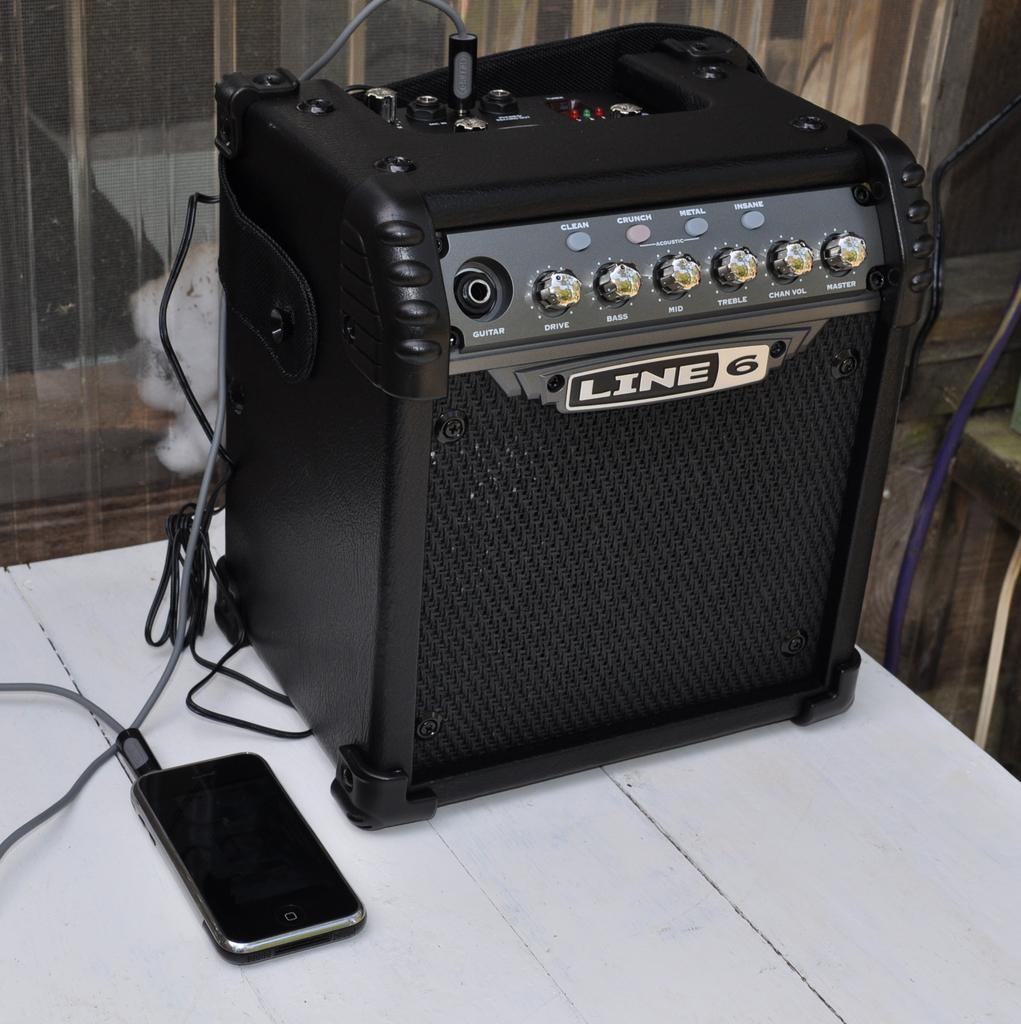<image>
Provide a brief description of the given image. Black amp on the table with the word LINE on it. 